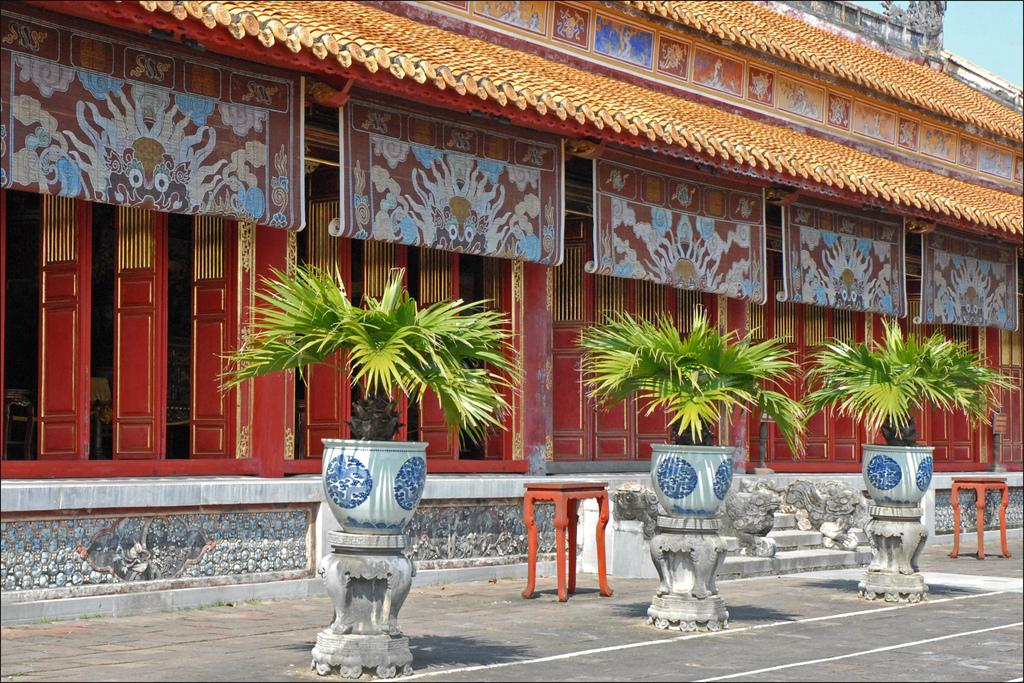What type of objects are present in the image related to plants? There are plant pots in the image. How many stools can be seen in the image? There are 2 stools in the image. What architectural feature is visible in the image? There are stairs in the image. What type of structure is depicted in the image? There is a building in the image. Can you describe the needle used for the attack in the image? There is no attack or needle present in the image. How does the change in the building's color affect the image? The building's color does not change in the image; it remains consistent. 